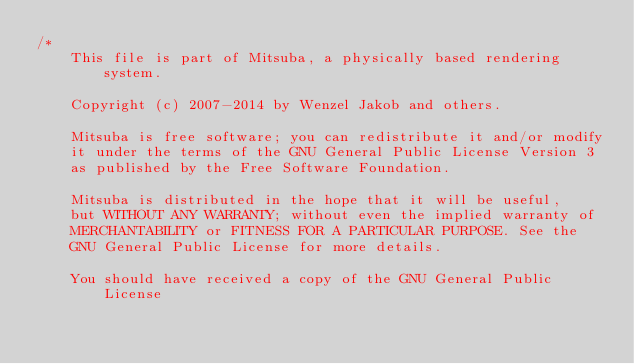<code> <loc_0><loc_0><loc_500><loc_500><_C++_>/*
    This file is part of Mitsuba, a physically based rendering system.

    Copyright (c) 2007-2014 by Wenzel Jakob and others.

    Mitsuba is free software; you can redistribute it and/or modify
    it under the terms of the GNU General Public License Version 3
    as published by the Free Software Foundation.

    Mitsuba is distributed in the hope that it will be useful,
    but WITHOUT ANY WARRANTY; without even the implied warranty of
    MERCHANTABILITY or FITNESS FOR A PARTICULAR PURPOSE. See the
    GNU General Public License for more details.

    You should have received a copy of the GNU General Public License</code> 